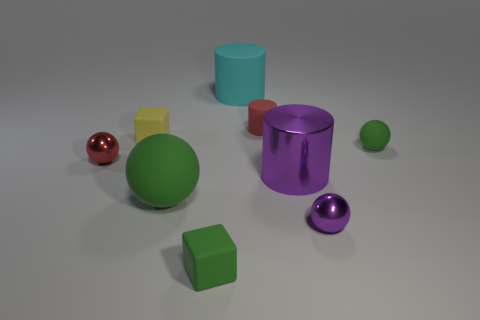Subtract all tiny matte balls. How many balls are left? 3 Subtract all green cylinders. How many green balls are left? 2 Subtract all purple cylinders. How many cylinders are left? 2 Add 1 large blue shiny cubes. How many objects exist? 10 Subtract all balls. How many objects are left? 5 Add 8 purple shiny things. How many purple shiny things are left? 10 Add 2 purple metal cylinders. How many purple metal cylinders exist? 3 Subtract 1 cyan cylinders. How many objects are left? 8 Subtract all gray cylinders. Subtract all blue blocks. How many cylinders are left? 3 Subtract all tiny yellow balls. Subtract all big matte objects. How many objects are left? 7 